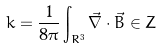<formula> <loc_0><loc_0><loc_500><loc_500>k = \frac { 1 } { 8 \pi } \int _ { R ^ { 3 } } \vec { \nabla } \cdot \vec { B } \in Z</formula> 